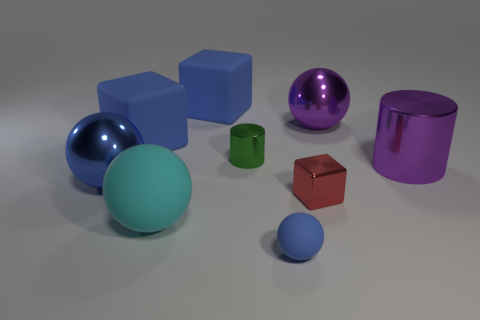Subtract all small blue rubber balls. How many balls are left? 3 Subtract all purple blocks. How many blue balls are left? 2 Add 1 tiny gray objects. How many objects exist? 10 Subtract all purple balls. How many balls are left? 3 Subtract all green spheres. Subtract all red cubes. How many spheres are left? 4 Subtract all cylinders. How many objects are left? 7 Subtract all matte balls. Subtract all rubber cubes. How many objects are left? 5 Add 6 big purple shiny spheres. How many big purple shiny spheres are left? 7 Add 4 purple shiny objects. How many purple shiny objects exist? 6 Subtract 0 cyan cubes. How many objects are left? 9 